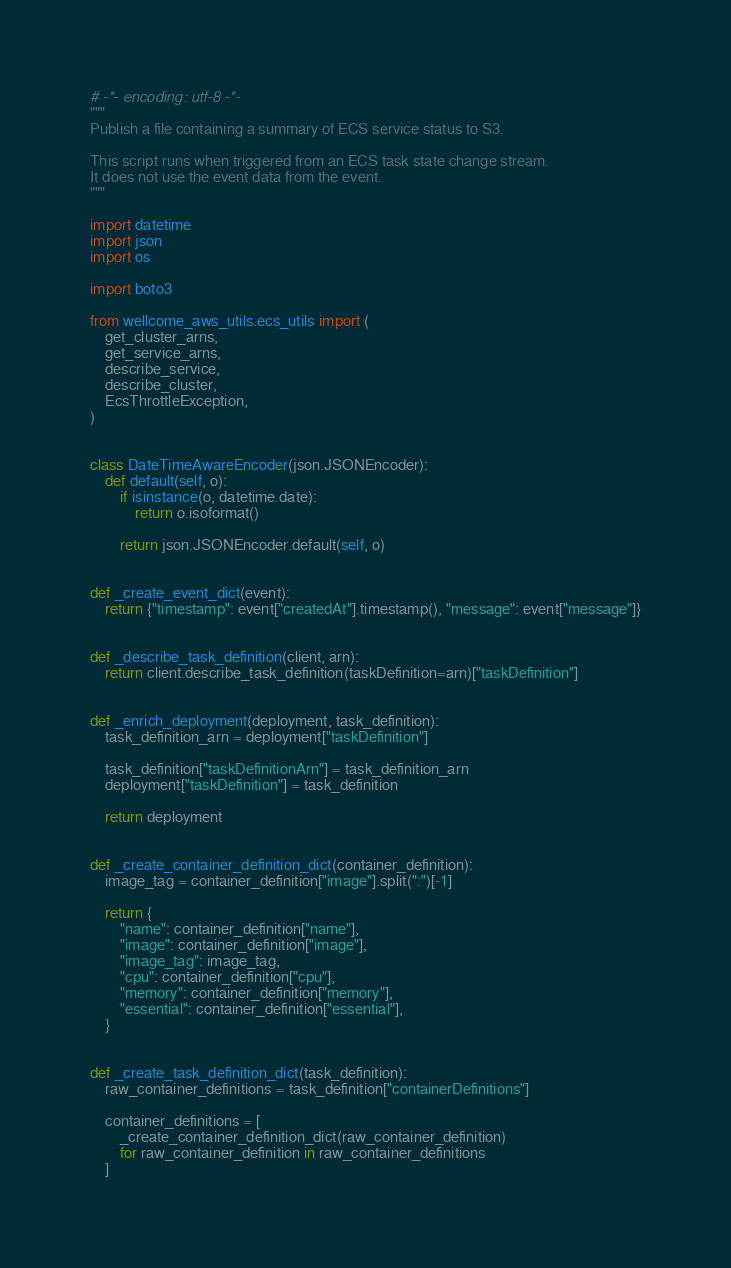Convert code to text. <code><loc_0><loc_0><loc_500><loc_500><_Python_># -*- encoding: utf-8 -*-
"""
Publish a file containing a summary of ECS service status to S3.

This script runs when triggered from an ECS task state change stream.
It does not use the event data from the event.
"""

import datetime
import json
import os

import boto3

from wellcome_aws_utils.ecs_utils import (
    get_cluster_arns,
    get_service_arns,
    describe_service,
    describe_cluster,
    EcsThrottleException,
)


class DateTimeAwareEncoder(json.JSONEncoder):
    def default(self, o):
        if isinstance(o, datetime.date):
            return o.isoformat()

        return json.JSONEncoder.default(self, o)


def _create_event_dict(event):
    return {"timestamp": event["createdAt"].timestamp(), "message": event["message"]}


def _describe_task_definition(client, arn):
    return client.describe_task_definition(taskDefinition=arn)["taskDefinition"]


def _enrich_deployment(deployment, task_definition):
    task_definition_arn = deployment["taskDefinition"]

    task_definition["taskDefinitionArn"] = task_definition_arn
    deployment["taskDefinition"] = task_definition

    return deployment


def _create_container_definition_dict(container_definition):
    image_tag = container_definition["image"].split(":")[-1]

    return {
        "name": container_definition["name"],
        "image": container_definition["image"],
        "image_tag": image_tag,
        "cpu": container_definition["cpu"],
        "memory": container_definition["memory"],
        "essential": container_definition["essential"],
    }


def _create_task_definition_dict(task_definition):
    raw_container_definitions = task_definition["containerDefinitions"]

    container_definitions = [
        _create_container_definition_dict(raw_container_definition)
        for raw_container_definition in raw_container_definitions
    ]
</code> 